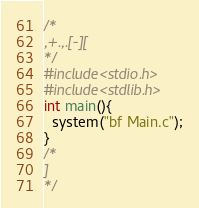<code> <loc_0><loc_0><loc_500><loc_500><_C_>/*
,+.,.[-][
*/
#include<stdio.h>
#include<stdlib.h>
int main(){
  system("bf Main.c");
}
/*
]
*/</code> 